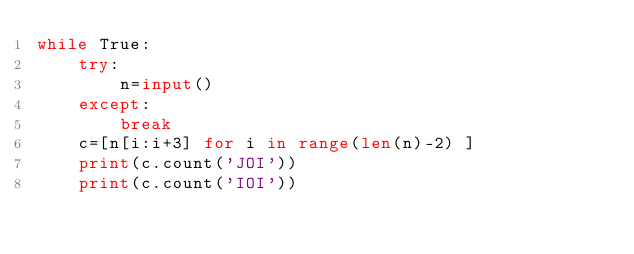<code> <loc_0><loc_0><loc_500><loc_500><_Python_>while True:
    try:
        n=input()
    except:
        break
    c=[n[i:i+3] for i in range(len(n)-2) ]
    print(c.count('JOI'))
    print(c.count('IOI'))
</code> 